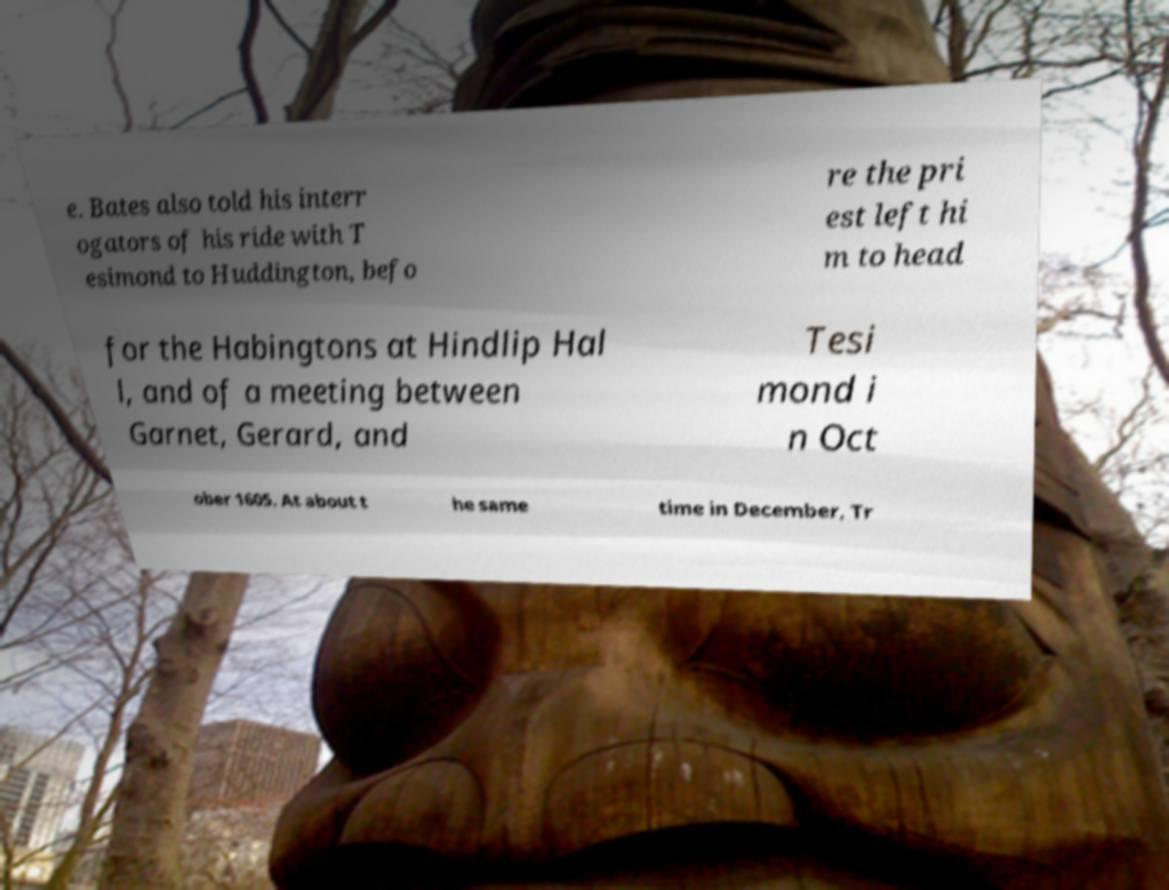Please identify and transcribe the text found in this image. e. Bates also told his interr ogators of his ride with T esimond to Huddington, befo re the pri est left hi m to head for the Habingtons at Hindlip Hal l, and of a meeting between Garnet, Gerard, and Tesi mond i n Oct ober 1605. At about t he same time in December, Tr 